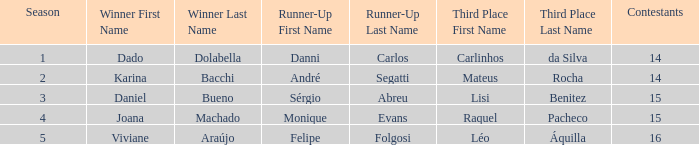Who finished in third place when the winner was Karina Bacchi?  Mateus Rocha. 